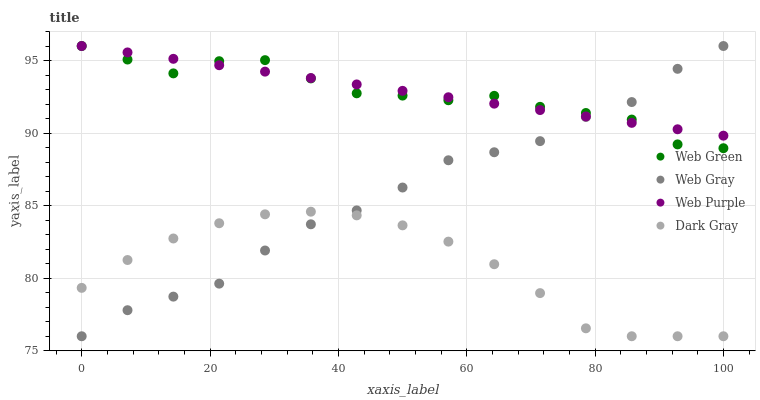Does Dark Gray have the minimum area under the curve?
Answer yes or no. Yes. Does Web Purple have the maximum area under the curve?
Answer yes or no. Yes. Does Web Gray have the minimum area under the curve?
Answer yes or no. No. Does Web Gray have the maximum area under the curve?
Answer yes or no. No. Is Web Purple the smoothest?
Answer yes or no. Yes. Is Web Green the roughest?
Answer yes or no. Yes. Is Web Gray the smoothest?
Answer yes or no. No. Is Web Gray the roughest?
Answer yes or no. No. Does Dark Gray have the lowest value?
Answer yes or no. Yes. Does Web Purple have the lowest value?
Answer yes or no. No. Does Web Green have the highest value?
Answer yes or no. Yes. Is Dark Gray less than Web Green?
Answer yes or no. Yes. Is Web Purple greater than Dark Gray?
Answer yes or no. Yes. Does Web Green intersect Web Purple?
Answer yes or no. Yes. Is Web Green less than Web Purple?
Answer yes or no. No. Is Web Green greater than Web Purple?
Answer yes or no. No. Does Dark Gray intersect Web Green?
Answer yes or no. No. 